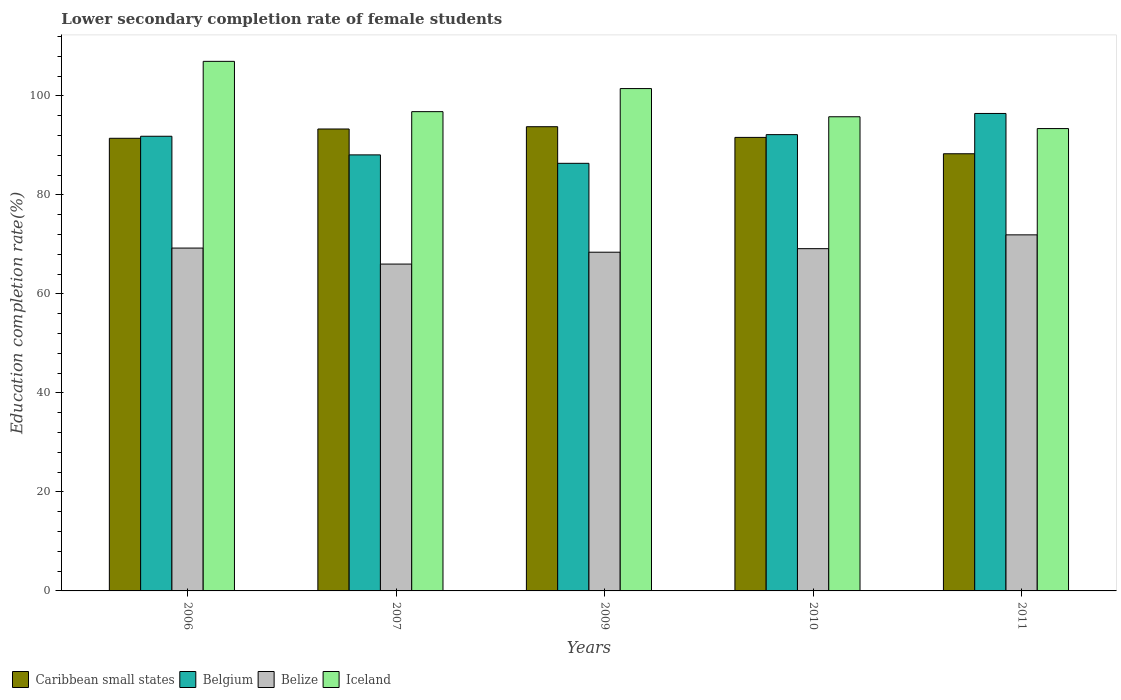Are the number of bars per tick equal to the number of legend labels?
Provide a succinct answer. Yes. Are the number of bars on each tick of the X-axis equal?
Provide a succinct answer. Yes. How many bars are there on the 1st tick from the left?
Offer a terse response. 4. What is the lower secondary completion rate of female students in Iceland in 2007?
Ensure brevity in your answer.  96.82. Across all years, what is the maximum lower secondary completion rate of female students in Caribbean small states?
Ensure brevity in your answer.  93.78. Across all years, what is the minimum lower secondary completion rate of female students in Belgium?
Make the answer very short. 86.38. In which year was the lower secondary completion rate of female students in Belgium maximum?
Keep it short and to the point. 2011. What is the total lower secondary completion rate of female students in Belize in the graph?
Provide a succinct answer. 344.78. What is the difference between the lower secondary completion rate of female students in Iceland in 2006 and that in 2007?
Your answer should be compact. 10.16. What is the difference between the lower secondary completion rate of female students in Belgium in 2007 and the lower secondary completion rate of female students in Belize in 2009?
Keep it short and to the point. 19.66. What is the average lower secondary completion rate of female students in Belgium per year?
Offer a terse response. 90.99. In the year 2011, what is the difference between the lower secondary completion rate of female students in Belize and lower secondary completion rate of female students in Caribbean small states?
Keep it short and to the point. -16.38. In how many years, is the lower secondary completion rate of female students in Iceland greater than 80 %?
Make the answer very short. 5. What is the ratio of the lower secondary completion rate of female students in Belgium in 2007 to that in 2011?
Keep it short and to the point. 0.91. Is the difference between the lower secondary completion rate of female students in Belize in 2006 and 2007 greater than the difference between the lower secondary completion rate of female students in Caribbean small states in 2006 and 2007?
Provide a succinct answer. Yes. What is the difference between the highest and the second highest lower secondary completion rate of female students in Belize?
Make the answer very short. 2.67. What is the difference between the highest and the lowest lower secondary completion rate of female students in Iceland?
Your response must be concise. 13.58. In how many years, is the lower secondary completion rate of female students in Caribbean small states greater than the average lower secondary completion rate of female students in Caribbean small states taken over all years?
Give a very brief answer. 2. Is the sum of the lower secondary completion rate of female students in Belgium in 2010 and 2011 greater than the maximum lower secondary completion rate of female students in Iceland across all years?
Offer a very short reply. Yes. Is it the case that in every year, the sum of the lower secondary completion rate of female students in Belgium and lower secondary completion rate of female students in Caribbean small states is greater than the sum of lower secondary completion rate of female students in Iceland and lower secondary completion rate of female students in Belize?
Provide a succinct answer. No. What does the 3rd bar from the left in 2006 represents?
Your answer should be very brief. Belize. What does the 2nd bar from the right in 2009 represents?
Offer a terse response. Belize. How many bars are there?
Keep it short and to the point. 20. Are all the bars in the graph horizontal?
Provide a succinct answer. No. How many years are there in the graph?
Your answer should be compact. 5. What is the difference between two consecutive major ticks on the Y-axis?
Offer a very short reply. 20. Where does the legend appear in the graph?
Provide a short and direct response. Bottom left. How many legend labels are there?
Keep it short and to the point. 4. How are the legend labels stacked?
Ensure brevity in your answer.  Horizontal. What is the title of the graph?
Ensure brevity in your answer.  Lower secondary completion rate of female students. Does "Azerbaijan" appear as one of the legend labels in the graph?
Offer a terse response. No. What is the label or title of the Y-axis?
Your answer should be compact. Education completion rate(%). What is the Education completion rate(%) in Caribbean small states in 2006?
Make the answer very short. 91.44. What is the Education completion rate(%) in Belgium in 2006?
Provide a succinct answer. 91.85. What is the Education completion rate(%) of Belize in 2006?
Give a very brief answer. 69.26. What is the Education completion rate(%) in Iceland in 2006?
Ensure brevity in your answer.  106.98. What is the Education completion rate(%) of Caribbean small states in 2007?
Offer a terse response. 93.32. What is the Education completion rate(%) of Belgium in 2007?
Your response must be concise. 88.09. What is the Education completion rate(%) in Belize in 2007?
Offer a very short reply. 66.03. What is the Education completion rate(%) in Iceland in 2007?
Your answer should be compact. 96.82. What is the Education completion rate(%) of Caribbean small states in 2009?
Provide a succinct answer. 93.78. What is the Education completion rate(%) of Belgium in 2009?
Give a very brief answer. 86.38. What is the Education completion rate(%) in Belize in 2009?
Make the answer very short. 68.42. What is the Education completion rate(%) of Iceland in 2009?
Offer a very short reply. 101.48. What is the Education completion rate(%) in Caribbean small states in 2010?
Provide a short and direct response. 91.62. What is the Education completion rate(%) of Belgium in 2010?
Keep it short and to the point. 92.18. What is the Education completion rate(%) in Belize in 2010?
Offer a very short reply. 69.14. What is the Education completion rate(%) in Iceland in 2010?
Give a very brief answer. 95.79. What is the Education completion rate(%) in Caribbean small states in 2011?
Offer a very short reply. 88.31. What is the Education completion rate(%) of Belgium in 2011?
Give a very brief answer. 96.45. What is the Education completion rate(%) in Belize in 2011?
Your response must be concise. 71.93. What is the Education completion rate(%) of Iceland in 2011?
Provide a short and direct response. 93.4. Across all years, what is the maximum Education completion rate(%) of Caribbean small states?
Make the answer very short. 93.78. Across all years, what is the maximum Education completion rate(%) in Belgium?
Keep it short and to the point. 96.45. Across all years, what is the maximum Education completion rate(%) in Belize?
Your response must be concise. 71.93. Across all years, what is the maximum Education completion rate(%) of Iceland?
Your answer should be very brief. 106.98. Across all years, what is the minimum Education completion rate(%) in Caribbean small states?
Offer a very short reply. 88.31. Across all years, what is the minimum Education completion rate(%) in Belgium?
Your response must be concise. 86.38. Across all years, what is the minimum Education completion rate(%) in Belize?
Offer a terse response. 66.03. Across all years, what is the minimum Education completion rate(%) of Iceland?
Give a very brief answer. 93.4. What is the total Education completion rate(%) in Caribbean small states in the graph?
Offer a terse response. 458.46. What is the total Education completion rate(%) of Belgium in the graph?
Give a very brief answer. 454.94. What is the total Education completion rate(%) in Belize in the graph?
Provide a succinct answer. 344.78. What is the total Education completion rate(%) of Iceland in the graph?
Provide a succinct answer. 494.46. What is the difference between the Education completion rate(%) of Caribbean small states in 2006 and that in 2007?
Your answer should be compact. -1.88. What is the difference between the Education completion rate(%) of Belgium in 2006 and that in 2007?
Your answer should be very brief. 3.76. What is the difference between the Education completion rate(%) in Belize in 2006 and that in 2007?
Ensure brevity in your answer.  3.23. What is the difference between the Education completion rate(%) in Iceland in 2006 and that in 2007?
Ensure brevity in your answer.  10.16. What is the difference between the Education completion rate(%) of Caribbean small states in 2006 and that in 2009?
Offer a very short reply. -2.34. What is the difference between the Education completion rate(%) in Belgium in 2006 and that in 2009?
Make the answer very short. 5.47. What is the difference between the Education completion rate(%) of Belize in 2006 and that in 2009?
Provide a short and direct response. 0.84. What is the difference between the Education completion rate(%) of Iceland in 2006 and that in 2009?
Offer a terse response. 5.5. What is the difference between the Education completion rate(%) of Caribbean small states in 2006 and that in 2010?
Give a very brief answer. -0.18. What is the difference between the Education completion rate(%) in Belgium in 2006 and that in 2010?
Ensure brevity in your answer.  -0.33. What is the difference between the Education completion rate(%) of Belize in 2006 and that in 2010?
Make the answer very short. 0.12. What is the difference between the Education completion rate(%) in Iceland in 2006 and that in 2010?
Make the answer very short. 11.19. What is the difference between the Education completion rate(%) in Caribbean small states in 2006 and that in 2011?
Give a very brief answer. 3.13. What is the difference between the Education completion rate(%) in Belgium in 2006 and that in 2011?
Your response must be concise. -4.6. What is the difference between the Education completion rate(%) of Belize in 2006 and that in 2011?
Provide a succinct answer. -2.67. What is the difference between the Education completion rate(%) in Iceland in 2006 and that in 2011?
Keep it short and to the point. 13.58. What is the difference between the Education completion rate(%) of Caribbean small states in 2007 and that in 2009?
Provide a succinct answer. -0.46. What is the difference between the Education completion rate(%) in Belgium in 2007 and that in 2009?
Your response must be concise. 1.71. What is the difference between the Education completion rate(%) in Belize in 2007 and that in 2009?
Keep it short and to the point. -2.4. What is the difference between the Education completion rate(%) of Iceland in 2007 and that in 2009?
Make the answer very short. -4.66. What is the difference between the Education completion rate(%) of Caribbean small states in 2007 and that in 2010?
Your answer should be compact. 1.7. What is the difference between the Education completion rate(%) of Belgium in 2007 and that in 2010?
Offer a very short reply. -4.09. What is the difference between the Education completion rate(%) in Belize in 2007 and that in 2010?
Provide a succinct answer. -3.11. What is the difference between the Education completion rate(%) of Iceland in 2007 and that in 2010?
Offer a very short reply. 1.03. What is the difference between the Education completion rate(%) of Caribbean small states in 2007 and that in 2011?
Offer a very short reply. 5. What is the difference between the Education completion rate(%) in Belgium in 2007 and that in 2011?
Your response must be concise. -8.37. What is the difference between the Education completion rate(%) of Belize in 2007 and that in 2011?
Keep it short and to the point. -5.9. What is the difference between the Education completion rate(%) of Iceland in 2007 and that in 2011?
Your answer should be very brief. 3.42. What is the difference between the Education completion rate(%) of Caribbean small states in 2009 and that in 2010?
Offer a terse response. 2.16. What is the difference between the Education completion rate(%) in Belgium in 2009 and that in 2010?
Ensure brevity in your answer.  -5.8. What is the difference between the Education completion rate(%) of Belize in 2009 and that in 2010?
Offer a very short reply. -0.71. What is the difference between the Education completion rate(%) in Iceland in 2009 and that in 2010?
Provide a short and direct response. 5.7. What is the difference between the Education completion rate(%) of Caribbean small states in 2009 and that in 2011?
Provide a succinct answer. 5.47. What is the difference between the Education completion rate(%) of Belgium in 2009 and that in 2011?
Your response must be concise. -10.07. What is the difference between the Education completion rate(%) of Belize in 2009 and that in 2011?
Keep it short and to the point. -3.5. What is the difference between the Education completion rate(%) of Iceland in 2009 and that in 2011?
Your answer should be compact. 8.08. What is the difference between the Education completion rate(%) of Caribbean small states in 2010 and that in 2011?
Make the answer very short. 3.31. What is the difference between the Education completion rate(%) of Belgium in 2010 and that in 2011?
Keep it short and to the point. -4.28. What is the difference between the Education completion rate(%) in Belize in 2010 and that in 2011?
Make the answer very short. -2.79. What is the difference between the Education completion rate(%) in Iceland in 2010 and that in 2011?
Offer a terse response. 2.39. What is the difference between the Education completion rate(%) of Caribbean small states in 2006 and the Education completion rate(%) of Belgium in 2007?
Offer a very short reply. 3.35. What is the difference between the Education completion rate(%) in Caribbean small states in 2006 and the Education completion rate(%) in Belize in 2007?
Provide a short and direct response. 25.41. What is the difference between the Education completion rate(%) in Caribbean small states in 2006 and the Education completion rate(%) in Iceland in 2007?
Your answer should be very brief. -5.38. What is the difference between the Education completion rate(%) of Belgium in 2006 and the Education completion rate(%) of Belize in 2007?
Offer a very short reply. 25.82. What is the difference between the Education completion rate(%) of Belgium in 2006 and the Education completion rate(%) of Iceland in 2007?
Provide a short and direct response. -4.97. What is the difference between the Education completion rate(%) in Belize in 2006 and the Education completion rate(%) in Iceland in 2007?
Provide a succinct answer. -27.56. What is the difference between the Education completion rate(%) in Caribbean small states in 2006 and the Education completion rate(%) in Belgium in 2009?
Offer a terse response. 5.06. What is the difference between the Education completion rate(%) of Caribbean small states in 2006 and the Education completion rate(%) of Belize in 2009?
Offer a very short reply. 23.01. What is the difference between the Education completion rate(%) of Caribbean small states in 2006 and the Education completion rate(%) of Iceland in 2009?
Make the answer very short. -10.04. What is the difference between the Education completion rate(%) in Belgium in 2006 and the Education completion rate(%) in Belize in 2009?
Offer a very short reply. 23.42. What is the difference between the Education completion rate(%) of Belgium in 2006 and the Education completion rate(%) of Iceland in 2009?
Your answer should be very brief. -9.63. What is the difference between the Education completion rate(%) in Belize in 2006 and the Education completion rate(%) in Iceland in 2009?
Provide a short and direct response. -32.22. What is the difference between the Education completion rate(%) in Caribbean small states in 2006 and the Education completion rate(%) in Belgium in 2010?
Make the answer very short. -0.74. What is the difference between the Education completion rate(%) in Caribbean small states in 2006 and the Education completion rate(%) in Belize in 2010?
Your answer should be compact. 22.3. What is the difference between the Education completion rate(%) in Caribbean small states in 2006 and the Education completion rate(%) in Iceland in 2010?
Your answer should be very brief. -4.35. What is the difference between the Education completion rate(%) in Belgium in 2006 and the Education completion rate(%) in Belize in 2010?
Offer a terse response. 22.71. What is the difference between the Education completion rate(%) in Belgium in 2006 and the Education completion rate(%) in Iceland in 2010?
Your answer should be compact. -3.94. What is the difference between the Education completion rate(%) in Belize in 2006 and the Education completion rate(%) in Iceland in 2010?
Your answer should be very brief. -26.53. What is the difference between the Education completion rate(%) of Caribbean small states in 2006 and the Education completion rate(%) of Belgium in 2011?
Make the answer very short. -5.02. What is the difference between the Education completion rate(%) in Caribbean small states in 2006 and the Education completion rate(%) in Belize in 2011?
Provide a succinct answer. 19.51. What is the difference between the Education completion rate(%) of Caribbean small states in 2006 and the Education completion rate(%) of Iceland in 2011?
Provide a succinct answer. -1.96. What is the difference between the Education completion rate(%) of Belgium in 2006 and the Education completion rate(%) of Belize in 2011?
Give a very brief answer. 19.92. What is the difference between the Education completion rate(%) in Belgium in 2006 and the Education completion rate(%) in Iceland in 2011?
Your answer should be compact. -1.55. What is the difference between the Education completion rate(%) of Belize in 2006 and the Education completion rate(%) of Iceland in 2011?
Your response must be concise. -24.14. What is the difference between the Education completion rate(%) of Caribbean small states in 2007 and the Education completion rate(%) of Belgium in 2009?
Offer a very short reply. 6.94. What is the difference between the Education completion rate(%) of Caribbean small states in 2007 and the Education completion rate(%) of Belize in 2009?
Offer a terse response. 24.89. What is the difference between the Education completion rate(%) in Caribbean small states in 2007 and the Education completion rate(%) in Iceland in 2009?
Your answer should be compact. -8.16. What is the difference between the Education completion rate(%) in Belgium in 2007 and the Education completion rate(%) in Belize in 2009?
Ensure brevity in your answer.  19.66. What is the difference between the Education completion rate(%) of Belgium in 2007 and the Education completion rate(%) of Iceland in 2009?
Provide a short and direct response. -13.4. What is the difference between the Education completion rate(%) of Belize in 2007 and the Education completion rate(%) of Iceland in 2009?
Your answer should be compact. -35.45. What is the difference between the Education completion rate(%) of Caribbean small states in 2007 and the Education completion rate(%) of Belgium in 2010?
Ensure brevity in your answer.  1.14. What is the difference between the Education completion rate(%) in Caribbean small states in 2007 and the Education completion rate(%) in Belize in 2010?
Keep it short and to the point. 24.18. What is the difference between the Education completion rate(%) in Caribbean small states in 2007 and the Education completion rate(%) in Iceland in 2010?
Your response must be concise. -2.47. What is the difference between the Education completion rate(%) in Belgium in 2007 and the Education completion rate(%) in Belize in 2010?
Your answer should be compact. 18.95. What is the difference between the Education completion rate(%) of Belgium in 2007 and the Education completion rate(%) of Iceland in 2010?
Offer a terse response. -7.7. What is the difference between the Education completion rate(%) in Belize in 2007 and the Education completion rate(%) in Iceland in 2010?
Your answer should be compact. -29.76. What is the difference between the Education completion rate(%) of Caribbean small states in 2007 and the Education completion rate(%) of Belgium in 2011?
Make the answer very short. -3.14. What is the difference between the Education completion rate(%) of Caribbean small states in 2007 and the Education completion rate(%) of Belize in 2011?
Your response must be concise. 21.39. What is the difference between the Education completion rate(%) of Caribbean small states in 2007 and the Education completion rate(%) of Iceland in 2011?
Give a very brief answer. -0.08. What is the difference between the Education completion rate(%) of Belgium in 2007 and the Education completion rate(%) of Belize in 2011?
Offer a terse response. 16.16. What is the difference between the Education completion rate(%) of Belgium in 2007 and the Education completion rate(%) of Iceland in 2011?
Offer a very short reply. -5.31. What is the difference between the Education completion rate(%) of Belize in 2007 and the Education completion rate(%) of Iceland in 2011?
Provide a succinct answer. -27.37. What is the difference between the Education completion rate(%) in Caribbean small states in 2009 and the Education completion rate(%) in Belgium in 2010?
Ensure brevity in your answer.  1.6. What is the difference between the Education completion rate(%) in Caribbean small states in 2009 and the Education completion rate(%) in Belize in 2010?
Give a very brief answer. 24.64. What is the difference between the Education completion rate(%) in Caribbean small states in 2009 and the Education completion rate(%) in Iceland in 2010?
Provide a succinct answer. -2.01. What is the difference between the Education completion rate(%) in Belgium in 2009 and the Education completion rate(%) in Belize in 2010?
Ensure brevity in your answer.  17.24. What is the difference between the Education completion rate(%) of Belgium in 2009 and the Education completion rate(%) of Iceland in 2010?
Keep it short and to the point. -9.41. What is the difference between the Education completion rate(%) in Belize in 2009 and the Education completion rate(%) in Iceland in 2010?
Ensure brevity in your answer.  -27.36. What is the difference between the Education completion rate(%) of Caribbean small states in 2009 and the Education completion rate(%) of Belgium in 2011?
Ensure brevity in your answer.  -2.68. What is the difference between the Education completion rate(%) of Caribbean small states in 2009 and the Education completion rate(%) of Belize in 2011?
Offer a terse response. 21.85. What is the difference between the Education completion rate(%) in Caribbean small states in 2009 and the Education completion rate(%) in Iceland in 2011?
Offer a terse response. 0.38. What is the difference between the Education completion rate(%) of Belgium in 2009 and the Education completion rate(%) of Belize in 2011?
Make the answer very short. 14.45. What is the difference between the Education completion rate(%) in Belgium in 2009 and the Education completion rate(%) in Iceland in 2011?
Make the answer very short. -7.02. What is the difference between the Education completion rate(%) in Belize in 2009 and the Education completion rate(%) in Iceland in 2011?
Your answer should be compact. -24.97. What is the difference between the Education completion rate(%) in Caribbean small states in 2010 and the Education completion rate(%) in Belgium in 2011?
Make the answer very short. -4.84. What is the difference between the Education completion rate(%) in Caribbean small states in 2010 and the Education completion rate(%) in Belize in 2011?
Ensure brevity in your answer.  19.69. What is the difference between the Education completion rate(%) of Caribbean small states in 2010 and the Education completion rate(%) of Iceland in 2011?
Offer a very short reply. -1.78. What is the difference between the Education completion rate(%) of Belgium in 2010 and the Education completion rate(%) of Belize in 2011?
Your answer should be very brief. 20.25. What is the difference between the Education completion rate(%) in Belgium in 2010 and the Education completion rate(%) in Iceland in 2011?
Your answer should be very brief. -1.22. What is the difference between the Education completion rate(%) of Belize in 2010 and the Education completion rate(%) of Iceland in 2011?
Provide a short and direct response. -24.26. What is the average Education completion rate(%) of Caribbean small states per year?
Provide a succinct answer. 91.69. What is the average Education completion rate(%) of Belgium per year?
Give a very brief answer. 90.99. What is the average Education completion rate(%) in Belize per year?
Ensure brevity in your answer.  68.96. What is the average Education completion rate(%) of Iceland per year?
Provide a short and direct response. 98.89. In the year 2006, what is the difference between the Education completion rate(%) of Caribbean small states and Education completion rate(%) of Belgium?
Ensure brevity in your answer.  -0.41. In the year 2006, what is the difference between the Education completion rate(%) in Caribbean small states and Education completion rate(%) in Belize?
Your answer should be compact. 22.18. In the year 2006, what is the difference between the Education completion rate(%) in Caribbean small states and Education completion rate(%) in Iceland?
Your answer should be compact. -15.54. In the year 2006, what is the difference between the Education completion rate(%) in Belgium and Education completion rate(%) in Belize?
Your response must be concise. 22.59. In the year 2006, what is the difference between the Education completion rate(%) in Belgium and Education completion rate(%) in Iceland?
Provide a short and direct response. -15.13. In the year 2006, what is the difference between the Education completion rate(%) in Belize and Education completion rate(%) in Iceland?
Your response must be concise. -37.72. In the year 2007, what is the difference between the Education completion rate(%) of Caribbean small states and Education completion rate(%) of Belgium?
Your answer should be compact. 5.23. In the year 2007, what is the difference between the Education completion rate(%) in Caribbean small states and Education completion rate(%) in Belize?
Your response must be concise. 27.29. In the year 2007, what is the difference between the Education completion rate(%) of Caribbean small states and Education completion rate(%) of Iceland?
Your response must be concise. -3.5. In the year 2007, what is the difference between the Education completion rate(%) in Belgium and Education completion rate(%) in Belize?
Make the answer very short. 22.06. In the year 2007, what is the difference between the Education completion rate(%) of Belgium and Education completion rate(%) of Iceland?
Give a very brief answer. -8.73. In the year 2007, what is the difference between the Education completion rate(%) of Belize and Education completion rate(%) of Iceland?
Your answer should be very brief. -30.79. In the year 2009, what is the difference between the Education completion rate(%) in Caribbean small states and Education completion rate(%) in Belgium?
Provide a succinct answer. 7.4. In the year 2009, what is the difference between the Education completion rate(%) of Caribbean small states and Education completion rate(%) of Belize?
Keep it short and to the point. 25.35. In the year 2009, what is the difference between the Education completion rate(%) in Caribbean small states and Education completion rate(%) in Iceland?
Provide a short and direct response. -7.7. In the year 2009, what is the difference between the Education completion rate(%) in Belgium and Education completion rate(%) in Belize?
Give a very brief answer. 17.96. In the year 2009, what is the difference between the Education completion rate(%) in Belgium and Education completion rate(%) in Iceland?
Make the answer very short. -15.1. In the year 2009, what is the difference between the Education completion rate(%) in Belize and Education completion rate(%) in Iceland?
Ensure brevity in your answer.  -33.06. In the year 2010, what is the difference between the Education completion rate(%) of Caribbean small states and Education completion rate(%) of Belgium?
Your response must be concise. -0.56. In the year 2010, what is the difference between the Education completion rate(%) of Caribbean small states and Education completion rate(%) of Belize?
Your response must be concise. 22.48. In the year 2010, what is the difference between the Education completion rate(%) of Caribbean small states and Education completion rate(%) of Iceland?
Make the answer very short. -4.17. In the year 2010, what is the difference between the Education completion rate(%) of Belgium and Education completion rate(%) of Belize?
Provide a short and direct response. 23.04. In the year 2010, what is the difference between the Education completion rate(%) in Belgium and Education completion rate(%) in Iceland?
Provide a short and direct response. -3.61. In the year 2010, what is the difference between the Education completion rate(%) in Belize and Education completion rate(%) in Iceland?
Provide a succinct answer. -26.65. In the year 2011, what is the difference between the Education completion rate(%) in Caribbean small states and Education completion rate(%) in Belgium?
Your answer should be compact. -8.14. In the year 2011, what is the difference between the Education completion rate(%) in Caribbean small states and Education completion rate(%) in Belize?
Offer a terse response. 16.38. In the year 2011, what is the difference between the Education completion rate(%) in Caribbean small states and Education completion rate(%) in Iceland?
Ensure brevity in your answer.  -5.09. In the year 2011, what is the difference between the Education completion rate(%) in Belgium and Education completion rate(%) in Belize?
Provide a succinct answer. 24.52. In the year 2011, what is the difference between the Education completion rate(%) in Belgium and Education completion rate(%) in Iceland?
Keep it short and to the point. 3.05. In the year 2011, what is the difference between the Education completion rate(%) of Belize and Education completion rate(%) of Iceland?
Your answer should be compact. -21.47. What is the ratio of the Education completion rate(%) in Caribbean small states in 2006 to that in 2007?
Provide a succinct answer. 0.98. What is the ratio of the Education completion rate(%) of Belgium in 2006 to that in 2007?
Offer a terse response. 1.04. What is the ratio of the Education completion rate(%) of Belize in 2006 to that in 2007?
Your answer should be very brief. 1.05. What is the ratio of the Education completion rate(%) in Iceland in 2006 to that in 2007?
Offer a very short reply. 1.1. What is the ratio of the Education completion rate(%) of Caribbean small states in 2006 to that in 2009?
Keep it short and to the point. 0.97. What is the ratio of the Education completion rate(%) of Belgium in 2006 to that in 2009?
Your answer should be very brief. 1.06. What is the ratio of the Education completion rate(%) of Belize in 2006 to that in 2009?
Ensure brevity in your answer.  1.01. What is the ratio of the Education completion rate(%) in Iceland in 2006 to that in 2009?
Provide a succinct answer. 1.05. What is the ratio of the Education completion rate(%) of Caribbean small states in 2006 to that in 2010?
Offer a very short reply. 1. What is the ratio of the Education completion rate(%) of Belgium in 2006 to that in 2010?
Offer a terse response. 1. What is the ratio of the Education completion rate(%) in Iceland in 2006 to that in 2010?
Keep it short and to the point. 1.12. What is the ratio of the Education completion rate(%) of Caribbean small states in 2006 to that in 2011?
Offer a terse response. 1.04. What is the ratio of the Education completion rate(%) of Belgium in 2006 to that in 2011?
Your response must be concise. 0.95. What is the ratio of the Education completion rate(%) in Belize in 2006 to that in 2011?
Offer a terse response. 0.96. What is the ratio of the Education completion rate(%) in Iceland in 2006 to that in 2011?
Keep it short and to the point. 1.15. What is the ratio of the Education completion rate(%) of Belgium in 2007 to that in 2009?
Your answer should be very brief. 1.02. What is the ratio of the Education completion rate(%) in Iceland in 2007 to that in 2009?
Your answer should be very brief. 0.95. What is the ratio of the Education completion rate(%) of Caribbean small states in 2007 to that in 2010?
Your answer should be very brief. 1.02. What is the ratio of the Education completion rate(%) of Belgium in 2007 to that in 2010?
Make the answer very short. 0.96. What is the ratio of the Education completion rate(%) in Belize in 2007 to that in 2010?
Ensure brevity in your answer.  0.95. What is the ratio of the Education completion rate(%) in Iceland in 2007 to that in 2010?
Your answer should be compact. 1.01. What is the ratio of the Education completion rate(%) in Caribbean small states in 2007 to that in 2011?
Make the answer very short. 1.06. What is the ratio of the Education completion rate(%) of Belgium in 2007 to that in 2011?
Offer a terse response. 0.91. What is the ratio of the Education completion rate(%) in Belize in 2007 to that in 2011?
Offer a very short reply. 0.92. What is the ratio of the Education completion rate(%) of Iceland in 2007 to that in 2011?
Provide a short and direct response. 1.04. What is the ratio of the Education completion rate(%) of Caribbean small states in 2009 to that in 2010?
Keep it short and to the point. 1.02. What is the ratio of the Education completion rate(%) of Belgium in 2009 to that in 2010?
Your response must be concise. 0.94. What is the ratio of the Education completion rate(%) of Belize in 2009 to that in 2010?
Give a very brief answer. 0.99. What is the ratio of the Education completion rate(%) in Iceland in 2009 to that in 2010?
Provide a short and direct response. 1.06. What is the ratio of the Education completion rate(%) of Caribbean small states in 2009 to that in 2011?
Give a very brief answer. 1.06. What is the ratio of the Education completion rate(%) in Belgium in 2009 to that in 2011?
Make the answer very short. 0.9. What is the ratio of the Education completion rate(%) of Belize in 2009 to that in 2011?
Offer a terse response. 0.95. What is the ratio of the Education completion rate(%) of Iceland in 2009 to that in 2011?
Offer a very short reply. 1.09. What is the ratio of the Education completion rate(%) in Caribbean small states in 2010 to that in 2011?
Offer a terse response. 1.04. What is the ratio of the Education completion rate(%) of Belgium in 2010 to that in 2011?
Your answer should be very brief. 0.96. What is the ratio of the Education completion rate(%) in Belize in 2010 to that in 2011?
Your response must be concise. 0.96. What is the ratio of the Education completion rate(%) in Iceland in 2010 to that in 2011?
Keep it short and to the point. 1.03. What is the difference between the highest and the second highest Education completion rate(%) of Caribbean small states?
Ensure brevity in your answer.  0.46. What is the difference between the highest and the second highest Education completion rate(%) in Belgium?
Provide a short and direct response. 4.28. What is the difference between the highest and the second highest Education completion rate(%) of Belize?
Provide a succinct answer. 2.67. What is the difference between the highest and the second highest Education completion rate(%) in Iceland?
Ensure brevity in your answer.  5.5. What is the difference between the highest and the lowest Education completion rate(%) of Caribbean small states?
Your answer should be compact. 5.47. What is the difference between the highest and the lowest Education completion rate(%) in Belgium?
Provide a succinct answer. 10.07. What is the difference between the highest and the lowest Education completion rate(%) in Belize?
Your answer should be compact. 5.9. What is the difference between the highest and the lowest Education completion rate(%) in Iceland?
Your answer should be compact. 13.58. 